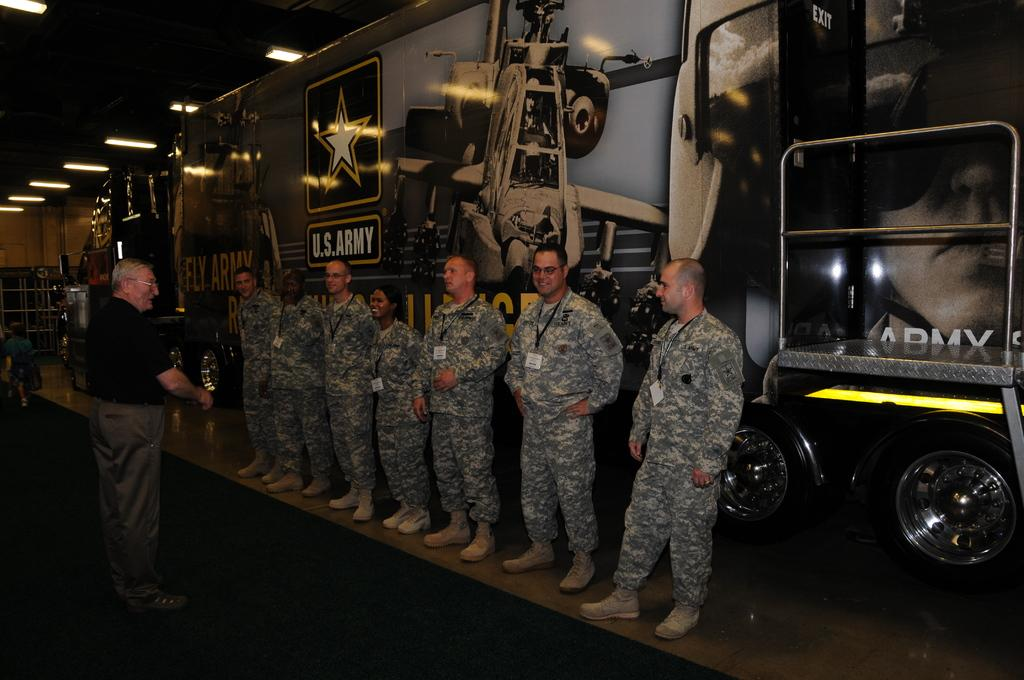What can be seen in the image involving people? There are people standing in the image. What type of vehicle is present in the image? There is a truck in the image. What feature of the truck is mentioned in the facts? The truck has wheels. What type of lighting is visible in the image? There are tube lights visible in the image. Can you describe the activity of a person in the image? There is a person walking in the left corner of the image. What color is the goldfish swimming in the image? There is no goldfish present in the image. What type of fabric is draped over the linen in the image? There is no linen present in the image. 